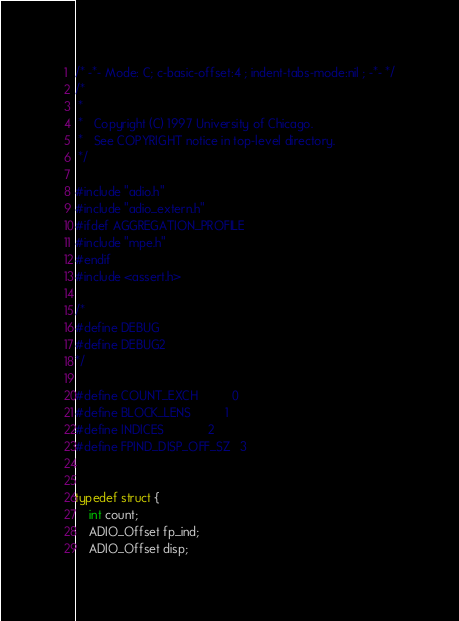<code> <loc_0><loc_0><loc_500><loc_500><_C_>/* -*- Mode: C; c-basic-offset:4 ; indent-tabs-mode:nil ; -*- */
/*
 *
 *   Copyright (C) 1997 University of Chicago.
 *   See COPYRIGHT notice in top-level directory.
 */

#include "adio.h"
#include "adio_extern.h"
#ifdef AGGREGATION_PROFILE
#include "mpe.h"
#endif
#include <assert.h>

/*
#define DEBUG
#define DEBUG2
*/

#define COUNT_EXCH          0
#define BLOCK_LENS          1
#define INDICES             2
#define FPIND_DISP_OFF_SZ   3


typedef struct {
    int count;
    ADIO_Offset fp_ind;
    ADIO_Offset disp;</code> 